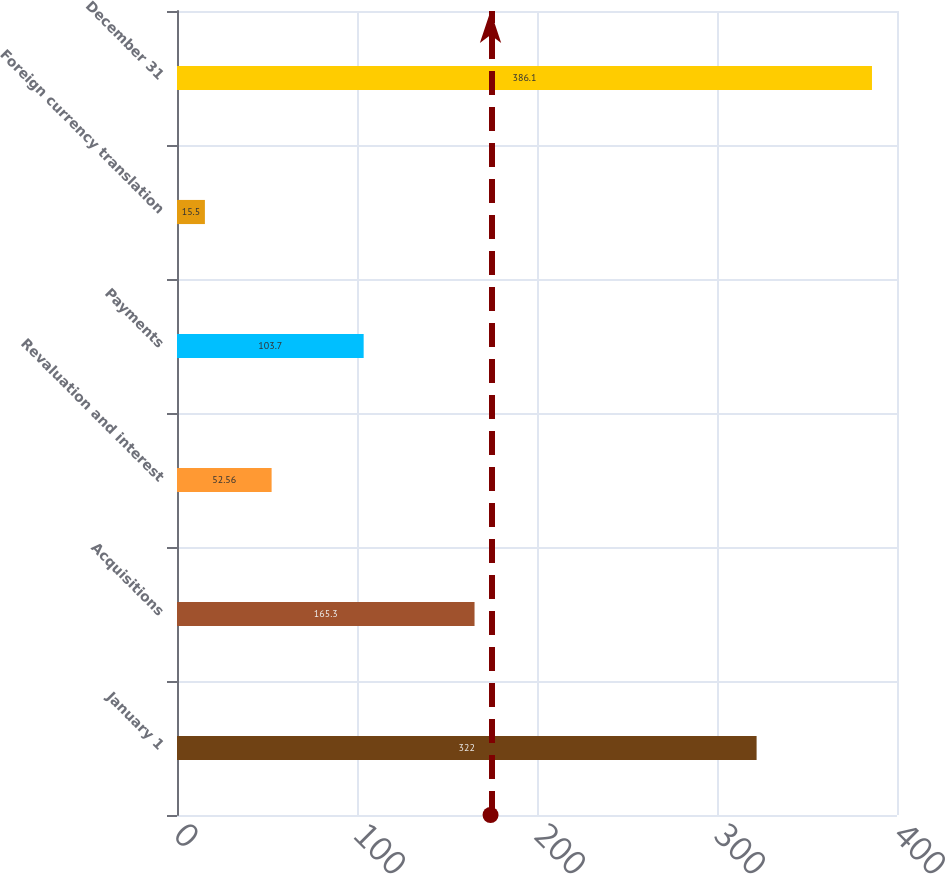Convert chart. <chart><loc_0><loc_0><loc_500><loc_500><bar_chart><fcel>January 1<fcel>Acquisitions<fcel>Revaluation and interest<fcel>Payments<fcel>Foreign currency translation<fcel>December 31<nl><fcel>322<fcel>165.3<fcel>52.56<fcel>103.7<fcel>15.5<fcel>386.1<nl></chart> 